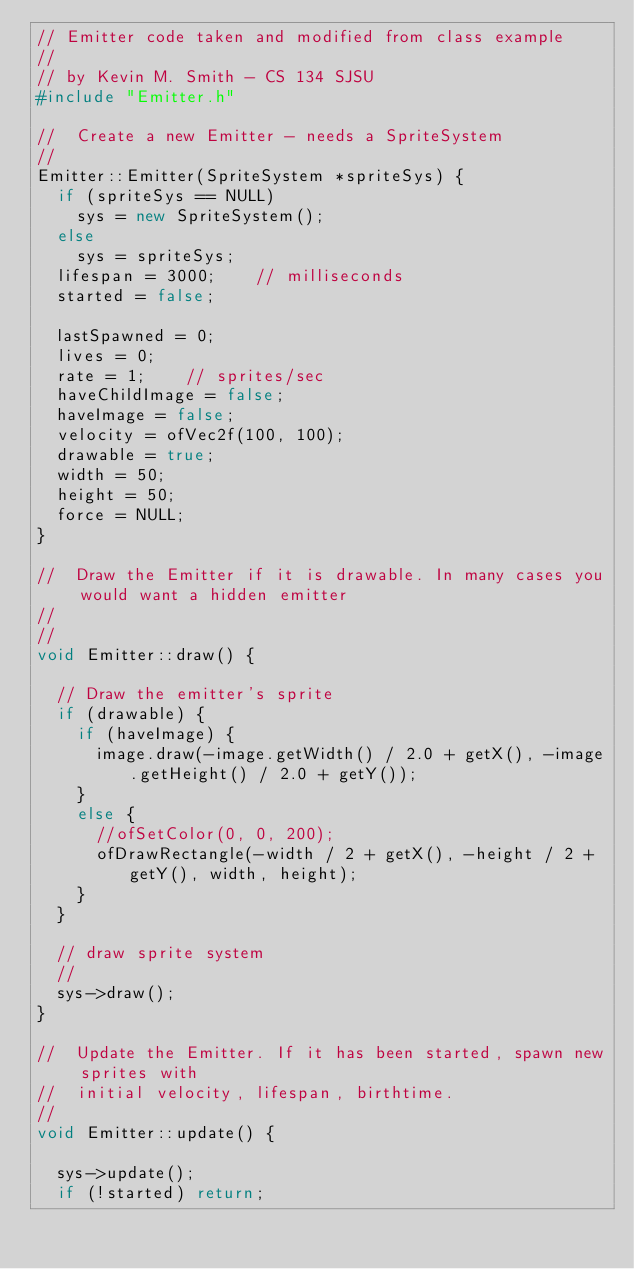Convert code to text. <code><loc_0><loc_0><loc_500><loc_500><_C++_>// Emitter code taken and modified from class example
//
// by Kevin M. Smith - CS 134 SJSU
#include "Emitter.h"

//  Create a new Emitter - needs a SpriteSystem
//
Emitter::Emitter(SpriteSystem *spriteSys) {
	if (spriteSys == NULL)
		sys = new SpriteSystem();
	else
		sys = spriteSys;
	lifespan = 3000;    // milliseconds
	started = false;

	lastSpawned = 0;
	lives = 0;
	rate = 1;    // sprites/sec
	haveChildImage = false;
	haveImage = false;
	velocity = ofVec2f(100, 100);
	drawable = true;
	width = 50;
	height = 50;
	force = NULL;
}

//  Draw the Emitter if it is drawable. In many cases you would want a hidden emitter
//
//
void Emitter::draw() {

	// Draw the emitter's sprite
	if (drawable) {
		if (haveImage) {
			image.draw(-image.getWidth() / 2.0 + getX(), -image.getHeight() / 2.0 + getY());
		}
		else {
			//ofSetColor(0, 0, 200);
			ofDrawRectangle(-width / 2 + getX(), -height / 2 + getY(), width, height);
		}
	}

	// draw sprite system
	//
	sys->draw();
}

//  Update the Emitter. If it has been started, spawn new sprites with
//  initial velocity, lifespan, birthtime.
//
void Emitter::update() {

	sys->update();
	if (!started) return;
</code> 